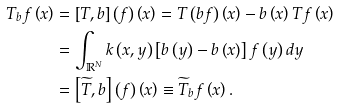<formula> <loc_0><loc_0><loc_500><loc_500>T _ { b } f \left ( x \right ) & = \left [ T , b \right ] \left ( f \right ) \left ( x \right ) = T \left ( b f \right ) \left ( x \right ) - b \left ( x \right ) T f \left ( x \right ) \\ & = \int _ { \mathbb { R } ^ { N } } k \left ( x , y \right ) \left [ b \left ( y \right ) - b \left ( x \right ) \right ] f \left ( y \right ) d y \\ & = \left [ \widetilde { T } , b \right ] \left ( f \right ) \left ( x \right ) \equiv \widetilde { T } _ { b } f \left ( x \right ) .</formula> 